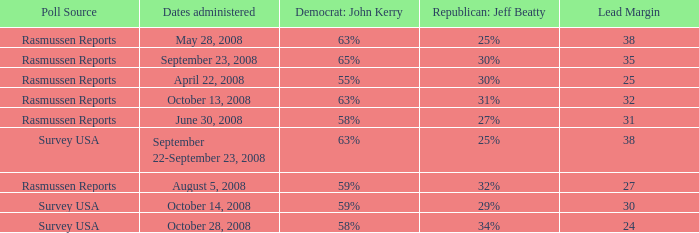Would you mind parsing the complete table? {'header': ['Poll Source', 'Dates administered', 'Democrat: John Kerry', 'Republican: Jeff Beatty', 'Lead Margin'], 'rows': [['Rasmussen Reports', 'May 28, 2008', '63%', '25%', '38'], ['Rasmussen Reports', 'September 23, 2008', '65%', '30%', '35'], ['Rasmussen Reports', 'April 22, 2008', '55%', '30%', '25'], ['Rasmussen Reports', 'October 13, 2008', '63%', '31%', '32'], ['Rasmussen Reports', 'June 30, 2008', '58%', '27%', '31'], ['Survey USA', 'September 22-September 23, 2008', '63%', '25%', '38'], ['Rasmussen Reports', 'August 5, 2008', '59%', '32%', '27'], ['Survey USA', 'October 14, 2008', '59%', '29%', '30'], ['Survey USA', 'October 28, 2008', '58%', '34%', '24']]} What is the maximum lead margin on august 5, 2008? 27.0. 